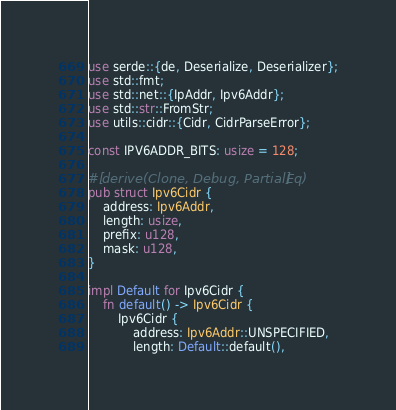Convert code to text. <code><loc_0><loc_0><loc_500><loc_500><_Rust_>use serde::{de, Deserialize, Deserializer};
use std::fmt;
use std::net::{IpAddr, Ipv6Addr};
use std::str::FromStr;
use utils::cidr::{Cidr, CidrParseError};

const IPV6ADDR_BITS: usize = 128;

#[derive(Clone, Debug, PartialEq)]
pub struct Ipv6Cidr {
    address: Ipv6Addr,
    length: usize,
    prefix: u128,
    mask: u128,
}

impl Default for Ipv6Cidr {
    fn default() -> Ipv6Cidr {
        Ipv6Cidr {
            address: Ipv6Addr::UNSPECIFIED,
            length: Default::default(),</code> 